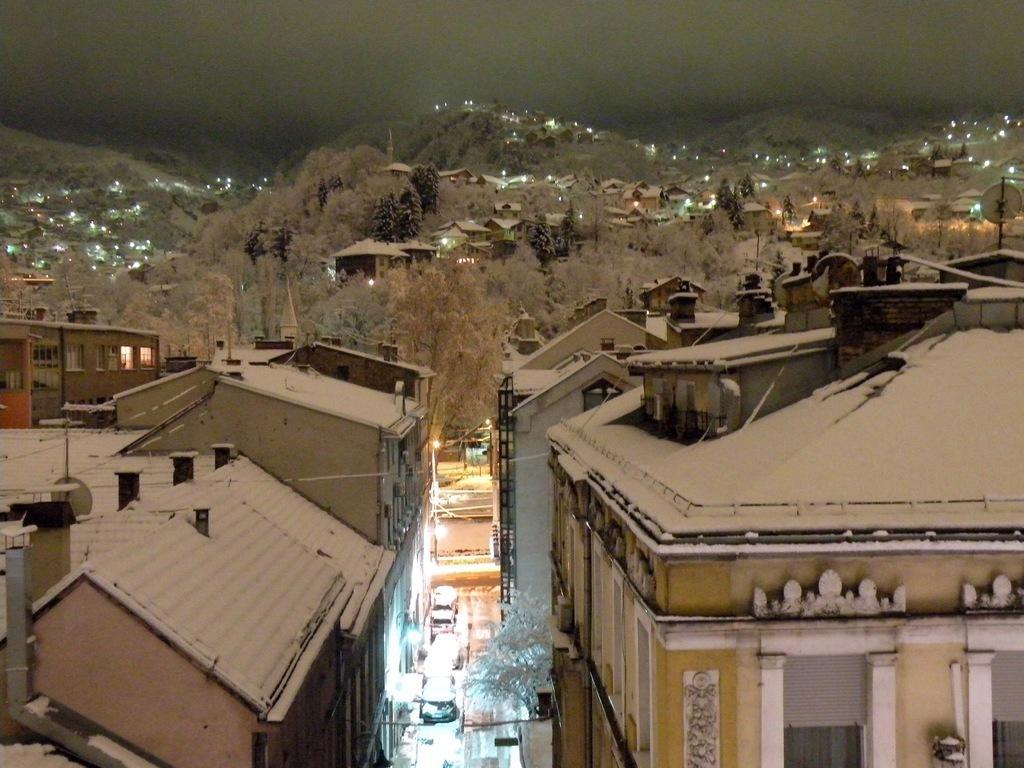Can you describe this image briefly? The picture is captured from the top view, there are many buildings and houses and most of them were covered with snow, behind the buildings there are some trees and the trees were also covered with snow. 